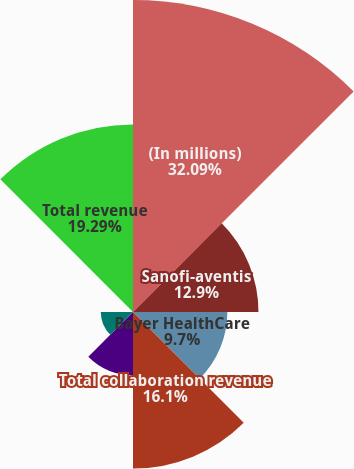Convert chart to OTSL. <chart><loc_0><loc_0><loc_500><loc_500><pie_chart><fcel>(In millions)<fcel>Sanofi-aventis<fcel>Bayer HealthCare<fcel>Total collaboration revenue<fcel>Technology licensing revenue<fcel>Net product sales<fcel>Contract research and other<fcel>Total revenue<nl><fcel>32.08%<fcel>12.9%<fcel>9.7%<fcel>16.1%<fcel>6.5%<fcel>3.31%<fcel>0.11%<fcel>19.29%<nl></chart> 